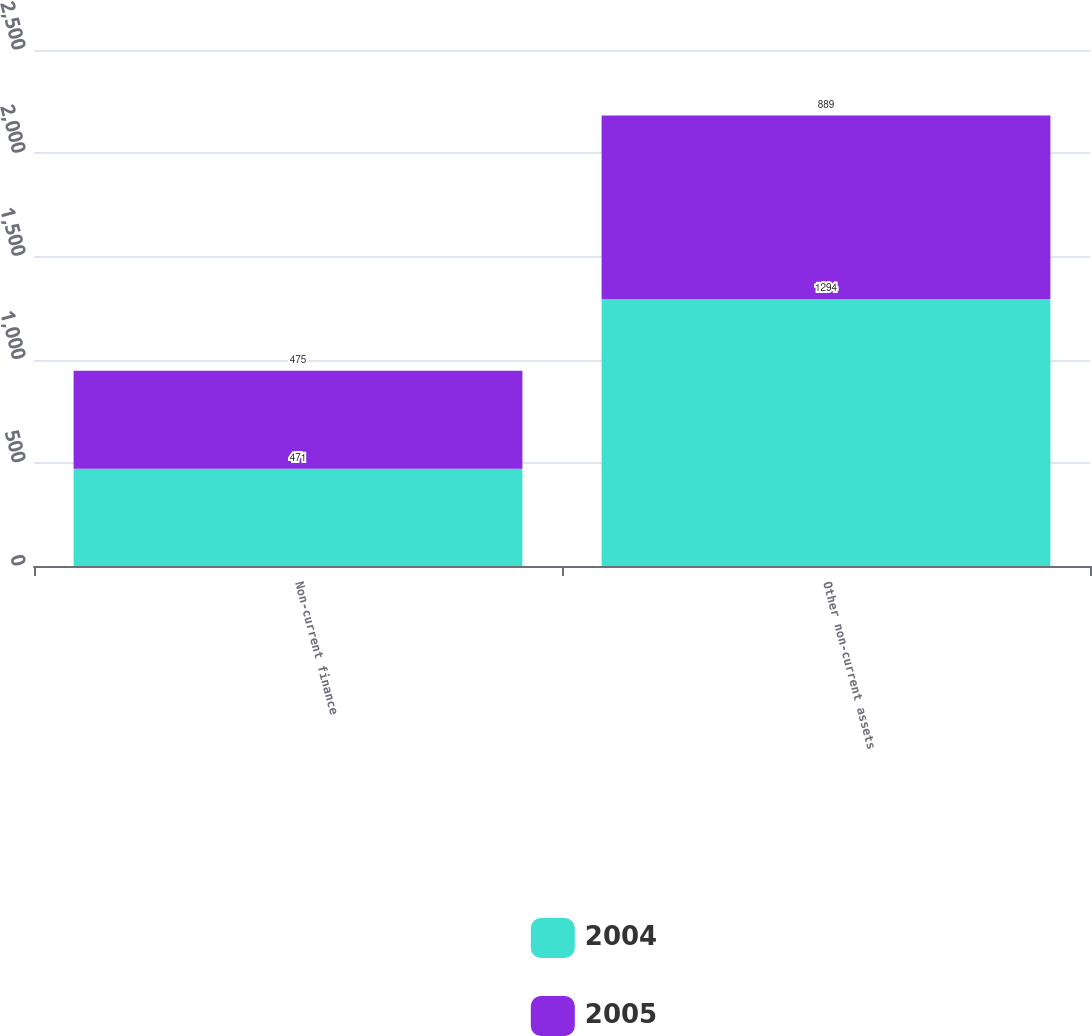Convert chart. <chart><loc_0><loc_0><loc_500><loc_500><stacked_bar_chart><ecel><fcel>Non-current finance<fcel>Other non-current assets<nl><fcel>2004<fcel>471<fcel>1294<nl><fcel>2005<fcel>475<fcel>889<nl></chart> 